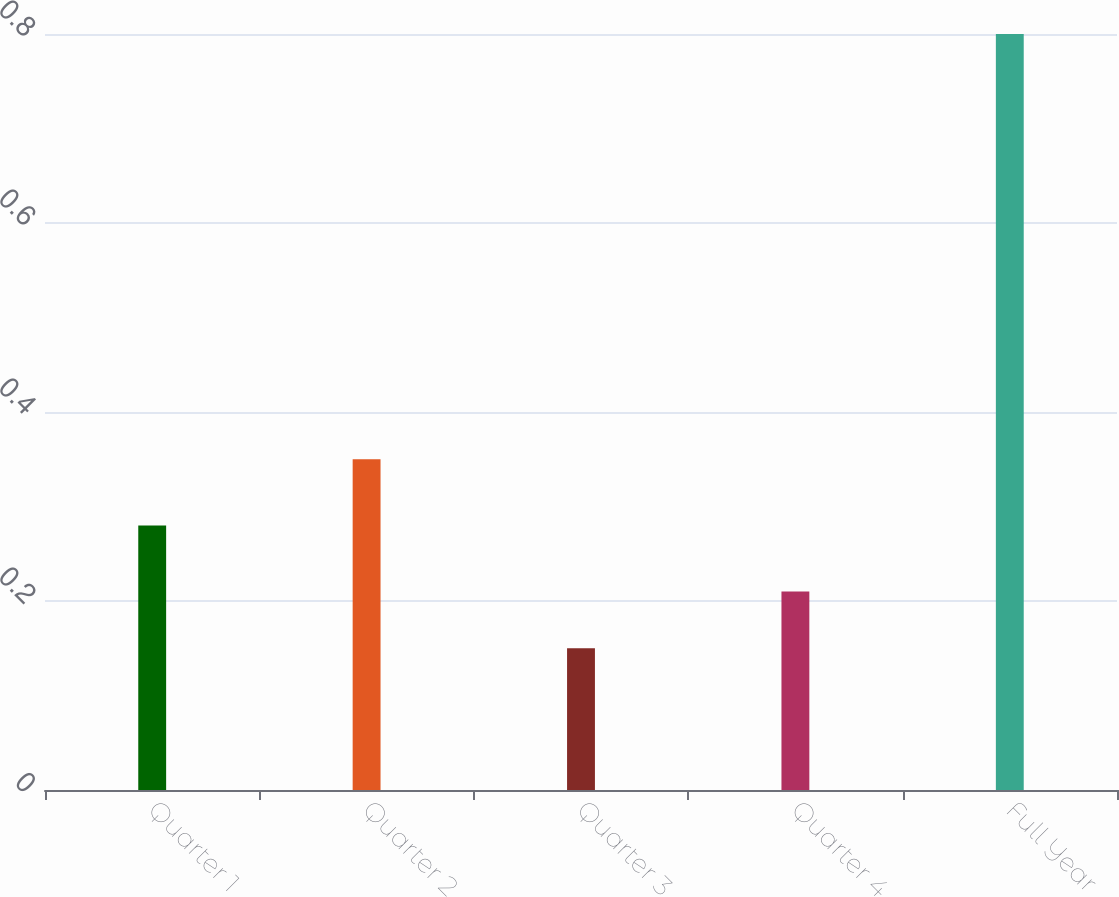Convert chart to OTSL. <chart><loc_0><loc_0><loc_500><loc_500><bar_chart><fcel>Quarter 1<fcel>Quarter 2<fcel>Quarter 3<fcel>Quarter 4<fcel>Full Year<nl><fcel>0.28<fcel>0.35<fcel>0.15<fcel>0.21<fcel>0.8<nl></chart> 